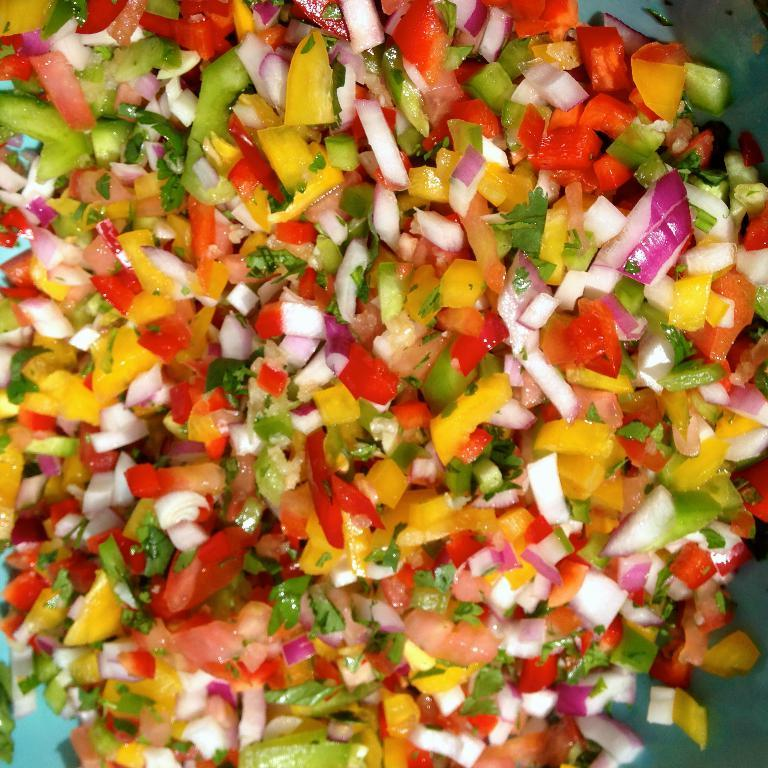What type of dish is featured in the image? The image contains a salad. What specific ingredients can be seen in the salad? There are onion pieces and tomato pieces in the salad. Are there any other ingredients in the salad besides onions and tomatoes? Yes, there are other items in the salad. What type of orange can be seen in the background of the image? There is no orange present in the image; it features a salad with onion and tomato pieces. What activities are taking place during the afternoon in the image? The image does not depict any specific activities or time of day, as it only shows a salad with various ingredients. 